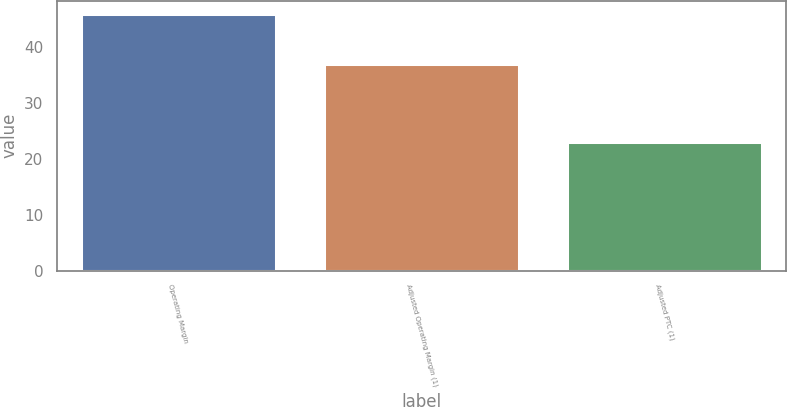Convert chart to OTSL. <chart><loc_0><loc_0><loc_500><loc_500><bar_chart><fcel>Operating Margin<fcel>Adjusted Operating Margin (1)<fcel>Adjusted PTC (1)<nl><fcel>46<fcel>37<fcel>23<nl></chart> 